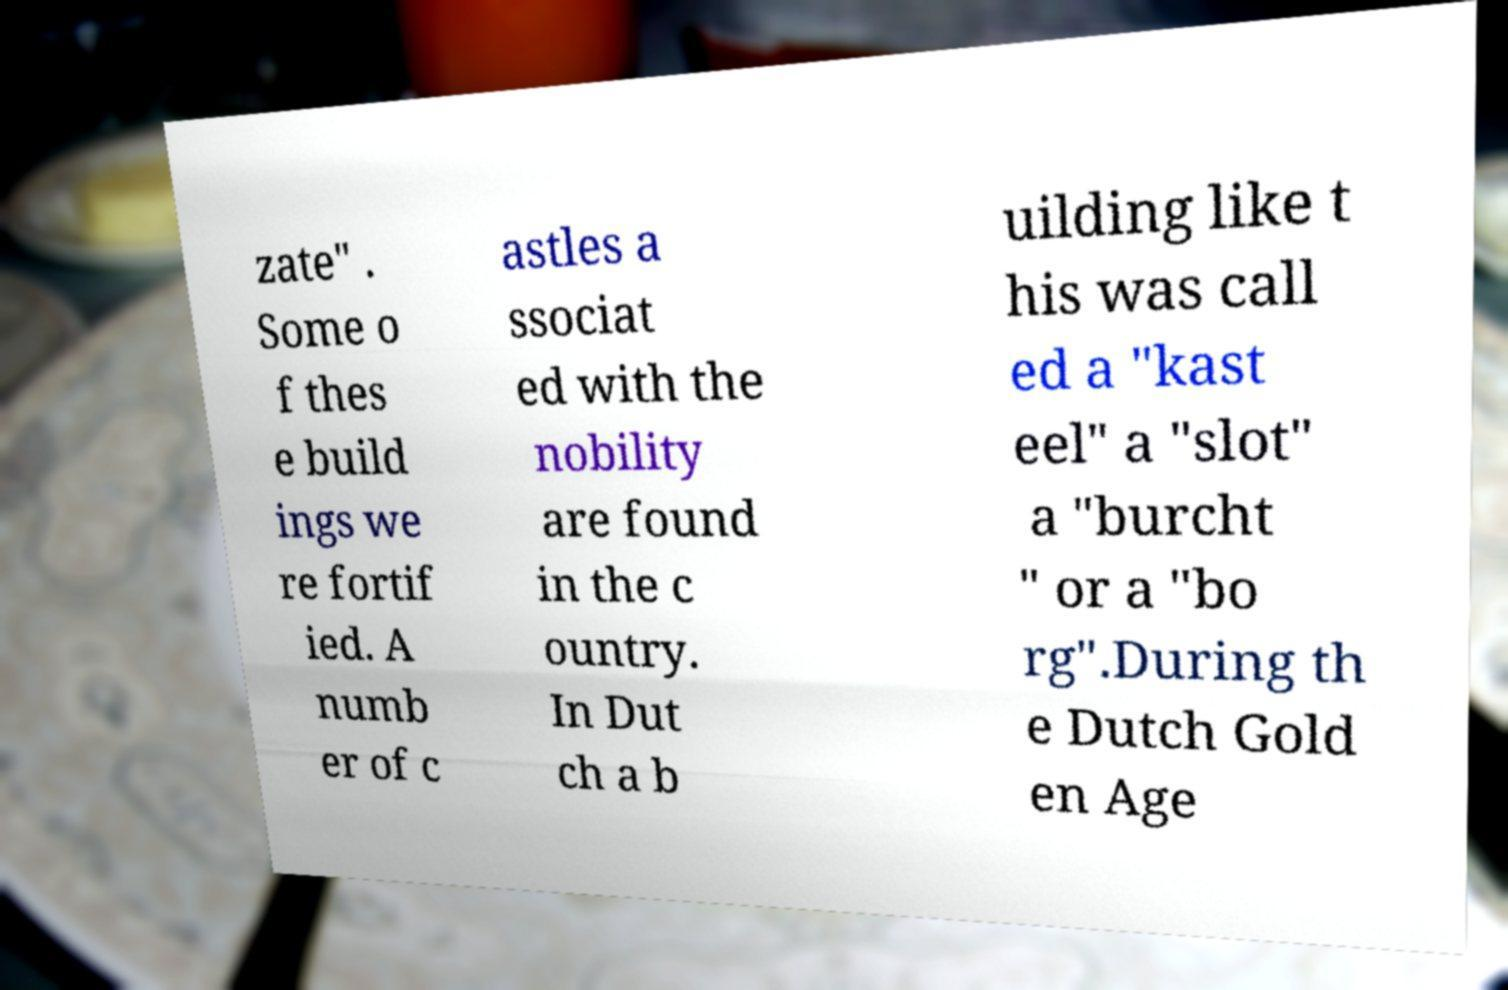Can you accurately transcribe the text from the provided image for me? zate" . Some o f thes e build ings we re fortif ied. A numb er of c astles a ssociat ed with the nobility are found in the c ountry. In Dut ch a b uilding like t his was call ed a "kast eel" a "slot" a "burcht " or a "bo rg".During th e Dutch Gold en Age 